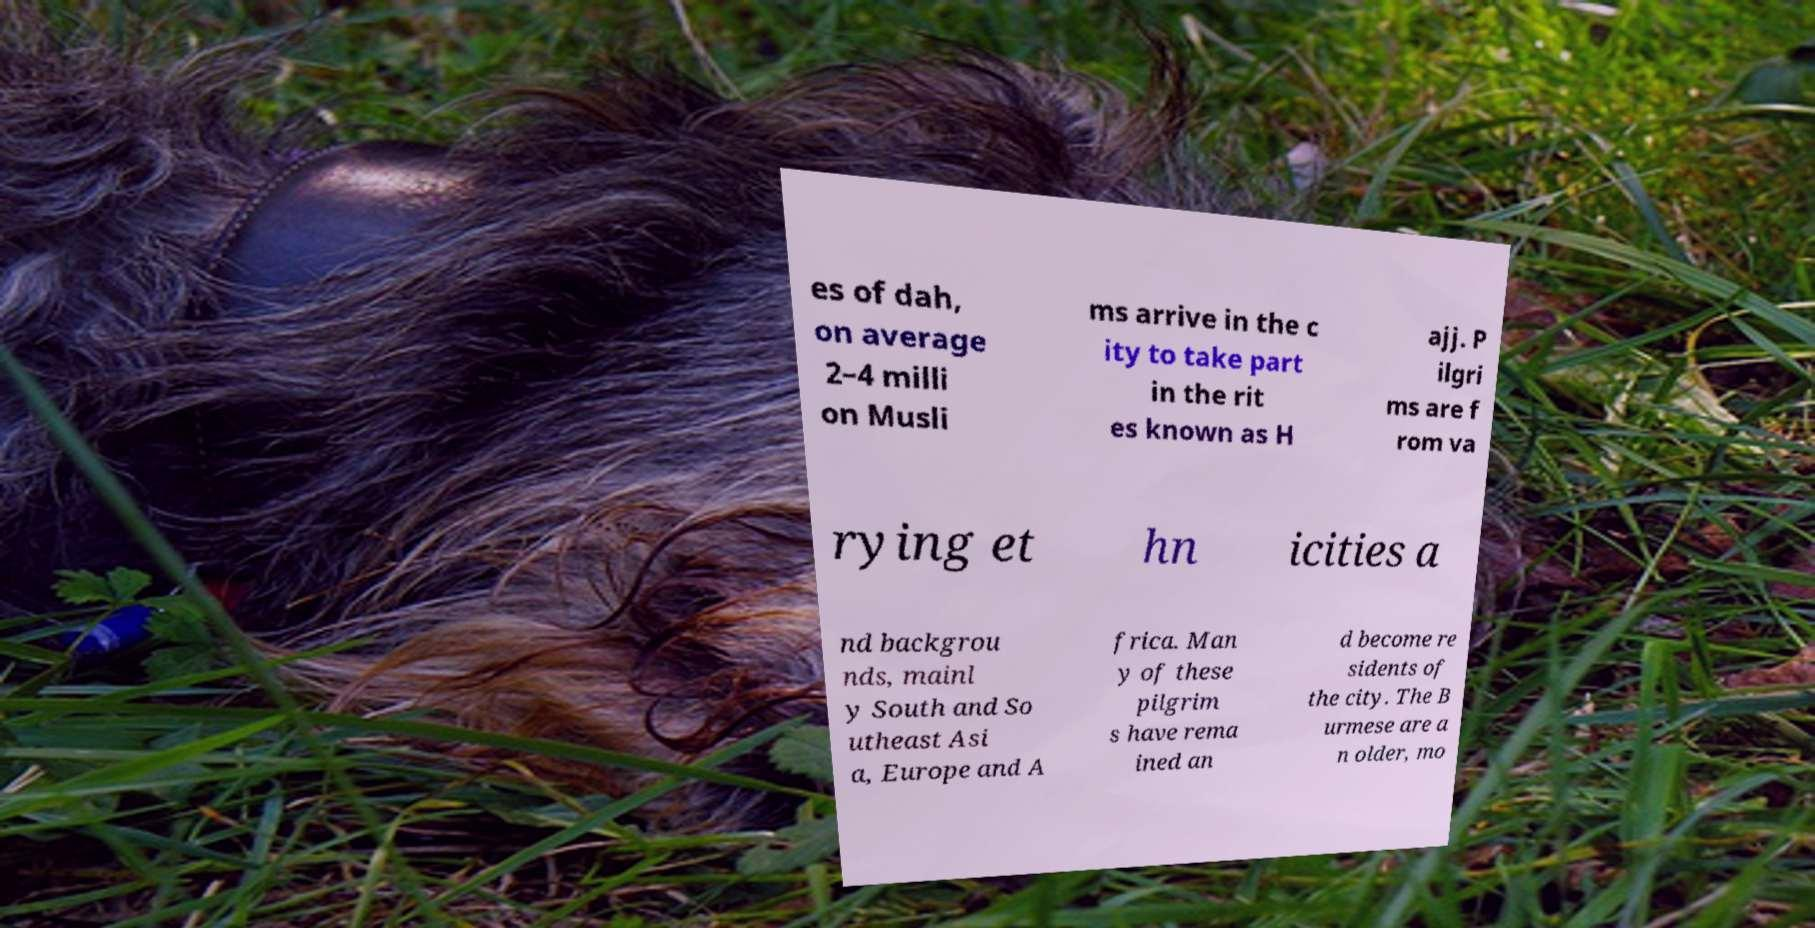There's text embedded in this image that I need extracted. Can you transcribe it verbatim? es of dah, on average 2–4 milli on Musli ms arrive in the c ity to take part in the rit es known as H ajj. P ilgri ms are f rom va rying et hn icities a nd backgrou nds, mainl y South and So utheast Asi a, Europe and A frica. Man y of these pilgrim s have rema ined an d become re sidents of the city. The B urmese are a n older, mo 